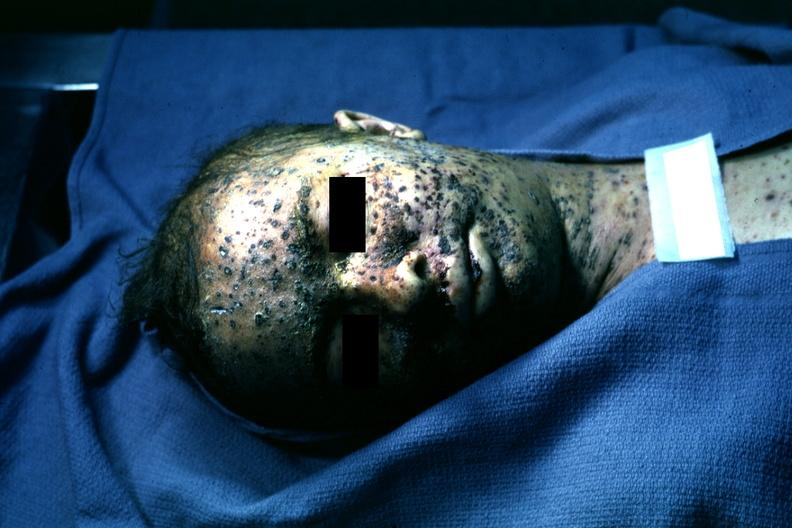what does this image show?
Answer the question using a single word or phrase. Extensive lesions 